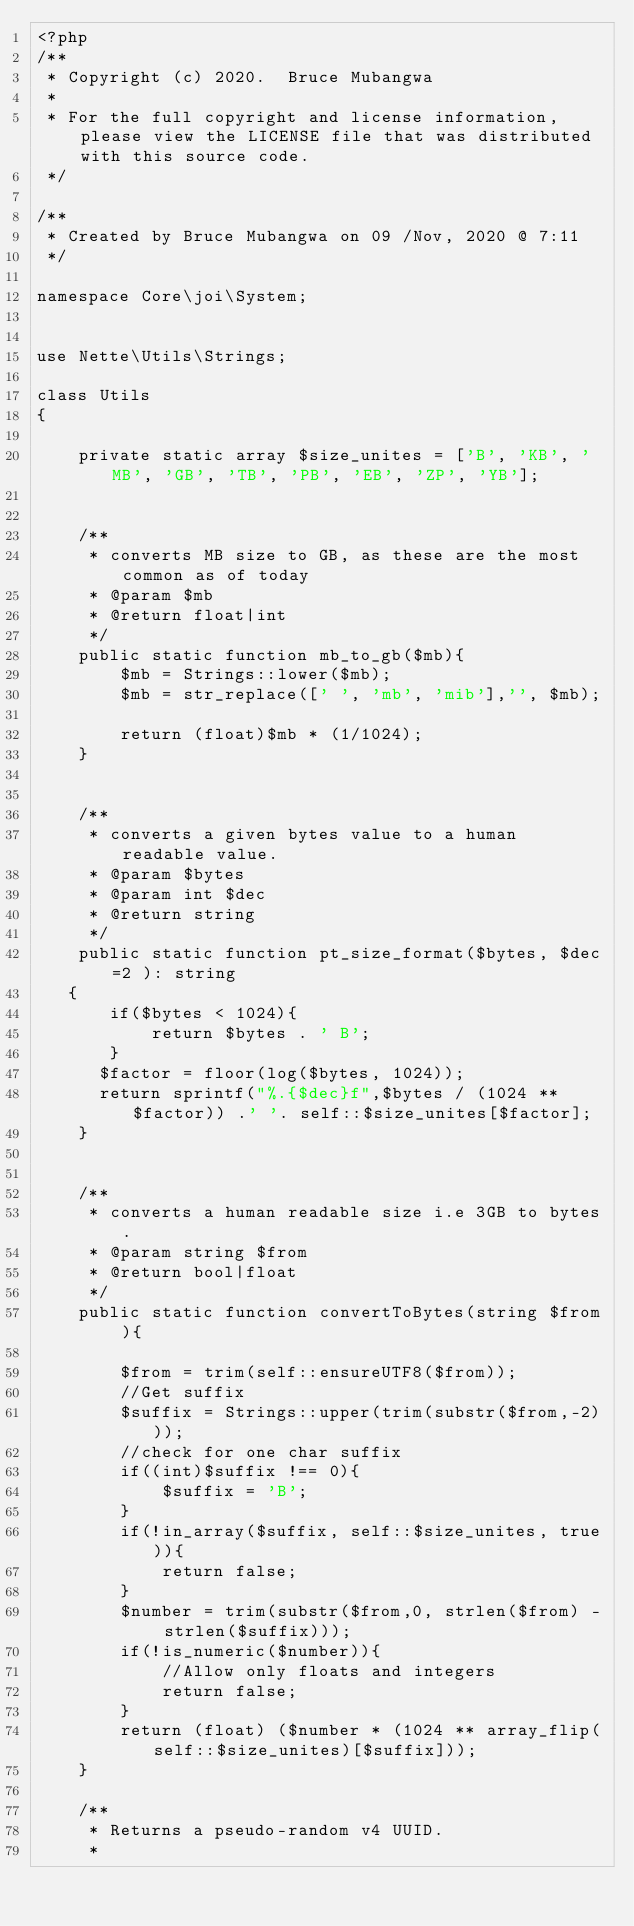<code> <loc_0><loc_0><loc_500><loc_500><_PHP_><?php
/**
 * Copyright (c) 2020.  Bruce Mubangwa
 *
 * For the full copyright and license information, please view the LICENSE file that was distributed with this source code.
 */

/**
 * Created by Bruce Mubangwa on 09 /Nov, 2020 @ 7:11
 */

namespace Core\joi\System;


use Nette\Utils\Strings;

class Utils
{

    private static array $size_unites = ['B', 'KB', 'MB', 'GB', 'TB', 'PB', 'EB', 'ZP', 'YB'];


    /**
     * converts MB size to GB, as these are the most common as of today
     * @param $mb
     * @return float|int
     */
    public static function mb_to_gb($mb){
        $mb = Strings::lower($mb);
        $mb = str_replace([' ', 'mb', 'mib'],'', $mb);

        return (float)$mb * (1/1024);
    }


    /**
     * converts a given bytes value to a human readable value.
     * @param $bytes
     * @param int $dec
     * @return string
     */
    public static function pt_size_format($bytes, $dec=2 ): string
   {
       if($bytes < 1024){
           return $bytes . ' B';
       }
      $factor = floor(log($bytes, 1024));
      return sprintf("%.{$dec}f",$bytes / (1024 ** $factor)) .' '. self::$size_unites[$factor];
    }


    /**
     * converts a human readable size i.e 3GB to bytes.
     * @param string $from
     * @return bool|float
     */
    public static function convertToBytes(string $from ){

        $from = trim(self::ensureUTF8($from));
        //Get suffix
        $suffix = Strings::upper(trim(substr($from,-2)));
        //check for one char suffix
        if((int)$suffix !== 0){
            $suffix = 'B';
        }
        if(!in_array($suffix, self::$size_unites, true)){
            return false;
        }
        $number = trim(substr($from,0, strlen($from) - strlen($suffix)));
        if(!is_numeric($number)){
            //Allow only floats and integers
            return false;
        }
        return (float) ($number * (1024 ** array_flip(self::$size_unites)[$suffix]));
    }

    /**
     * Returns a pseudo-random v4 UUID.
     *</code> 